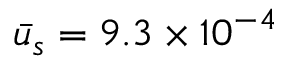<formula> <loc_0><loc_0><loc_500><loc_500>\bar { u } _ { s } = 9 . 3 \times { 1 0 ^ { - 4 } }</formula> 